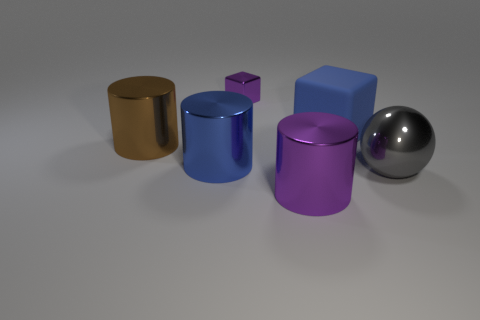Is there any other thing that is the same material as the big blue cube?
Give a very brief answer. No. Is there anything else that has the same size as the purple shiny cube?
Ensure brevity in your answer.  No. What size is the metal block?
Your answer should be compact. Small. What number of purple things are shiny objects or rubber blocks?
Provide a short and direct response. 2. What size is the purple object behind the cylinder that is on the right side of the small purple shiny object?
Provide a short and direct response. Small. Do the metal block and the shiny thing that is in front of the large sphere have the same color?
Ensure brevity in your answer.  Yes. How many other things are there of the same material as the purple cylinder?
Provide a short and direct response. 4. What is the shape of the big purple object that is the same material as the sphere?
Keep it short and to the point. Cylinder. Are there any other things that are the same color as the small metal object?
Give a very brief answer. Yes. Is the number of purple metallic things that are behind the big purple metal cylinder greater than the number of big yellow shiny cylinders?
Your response must be concise. Yes. 